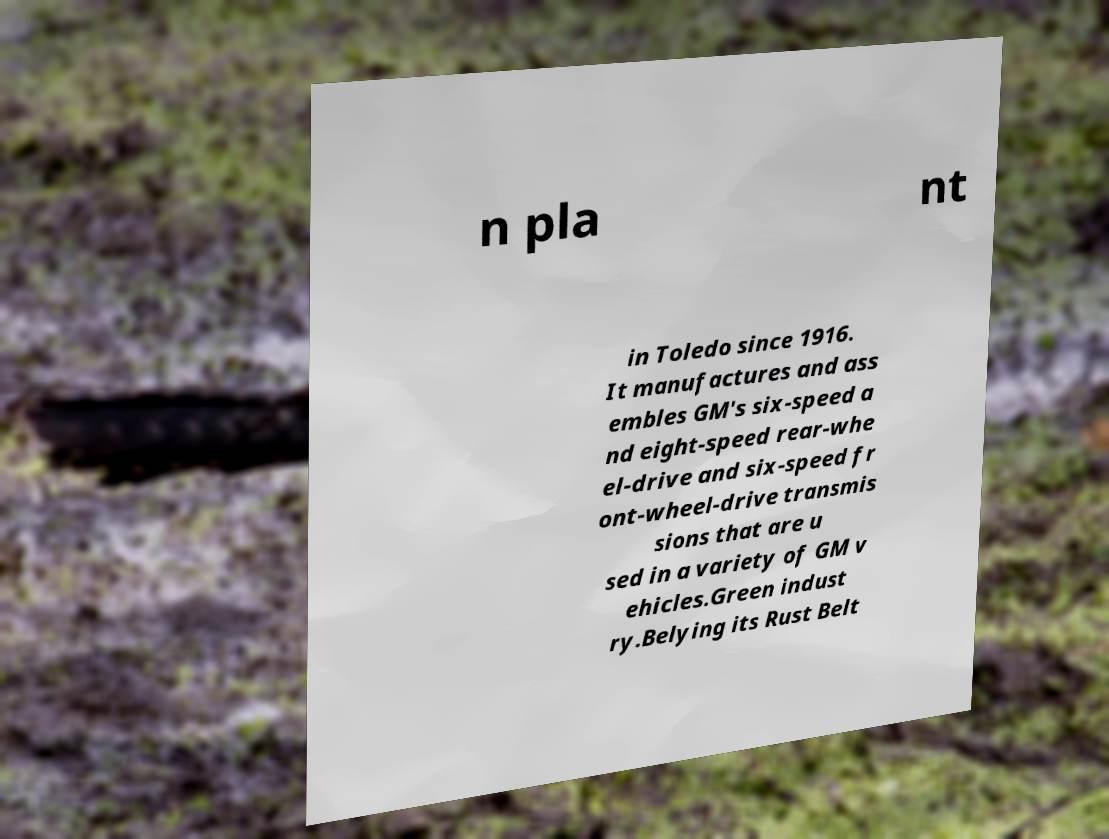Can you read and provide the text displayed in the image?This photo seems to have some interesting text. Can you extract and type it out for me? n pla nt in Toledo since 1916. It manufactures and ass embles GM's six-speed a nd eight-speed rear-whe el-drive and six-speed fr ont-wheel-drive transmis sions that are u sed in a variety of GM v ehicles.Green indust ry.Belying its Rust Belt 